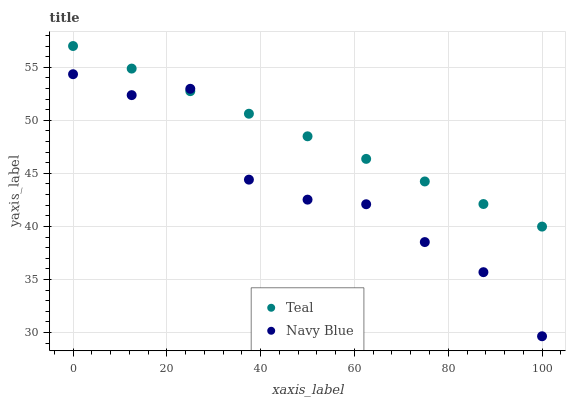Does Navy Blue have the minimum area under the curve?
Answer yes or no. Yes. Does Teal have the maximum area under the curve?
Answer yes or no. Yes. Does Teal have the minimum area under the curve?
Answer yes or no. No. Is Teal the smoothest?
Answer yes or no. Yes. Is Navy Blue the roughest?
Answer yes or no. Yes. Is Teal the roughest?
Answer yes or no. No. Does Navy Blue have the lowest value?
Answer yes or no. Yes. Does Teal have the lowest value?
Answer yes or no. No. Does Teal have the highest value?
Answer yes or no. Yes. Does Navy Blue intersect Teal?
Answer yes or no. Yes. Is Navy Blue less than Teal?
Answer yes or no. No. Is Navy Blue greater than Teal?
Answer yes or no. No. 